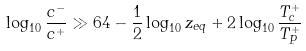Convert formula to latex. <formula><loc_0><loc_0><loc_500><loc_500>\log _ { 1 0 } { \frac { c ^ { - } } { c ^ { + } } } \gg 6 4 - { \frac { 1 } { 2 } } \log _ { 1 0 } z _ { e q } + 2 \log _ { 1 0 } { \frac { T _ { c } ^ { + } } { T _ { P } ^ { + } } }</formula> 